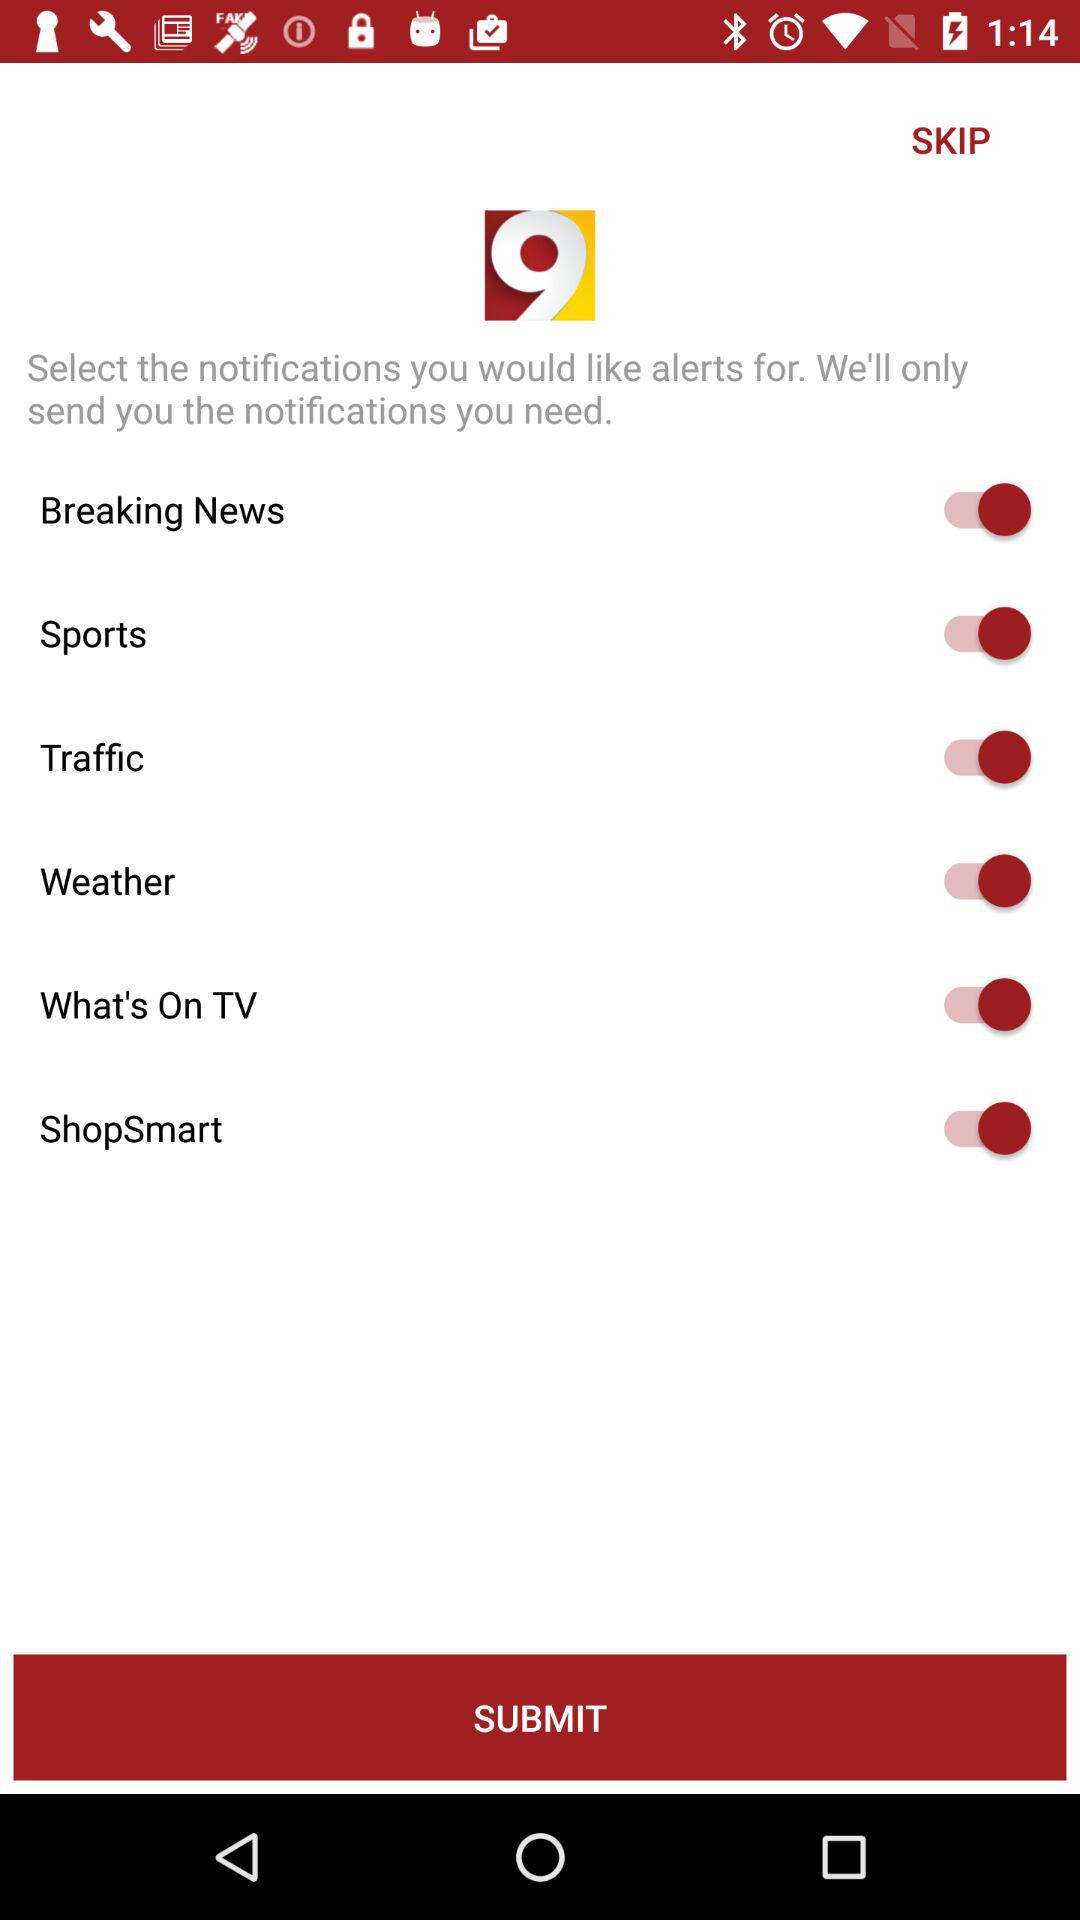What is the current status of "Sports"? The current status of "Sports" is "on". 